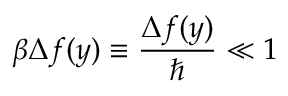<formula> <loc_0><loc_0><loc_500><loc_500>\beta \Delta f ( y ) \equiv \frac { \Delta f ( y ) } { } \ll 1</formula> 